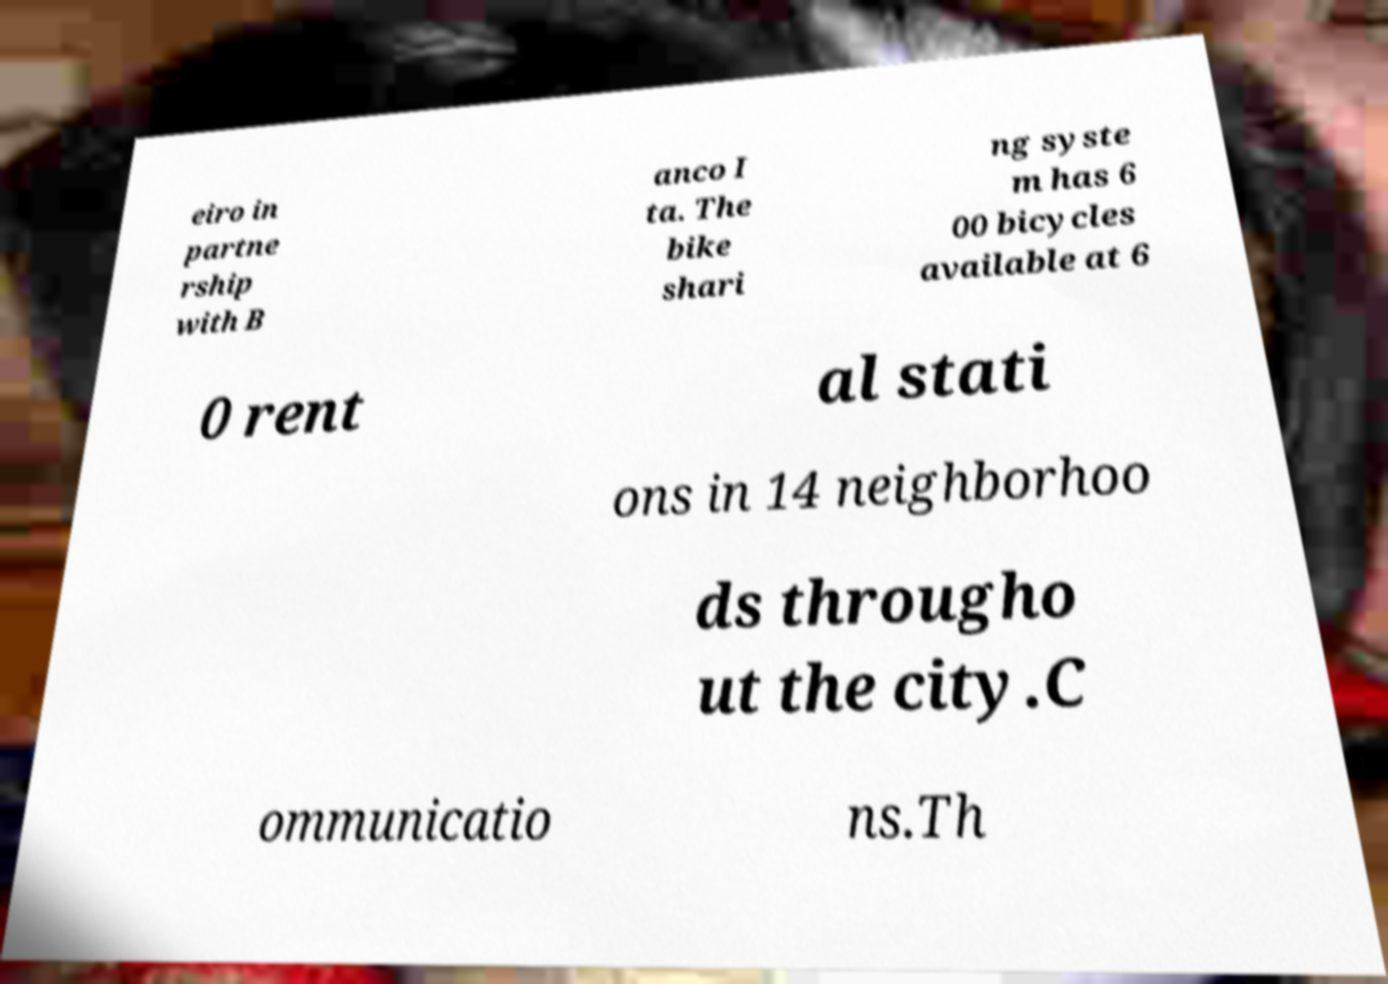For documentation purposes, I need the text within this image transcribed. Could you provide that? eiro in partne rship with B anco I ta. The bike shari ng syste m has 6 00 bicycles available at 6 0 rent al stati ons in 14 neighborhoo ds througho ut the city.C ommunicatio ns.Th 